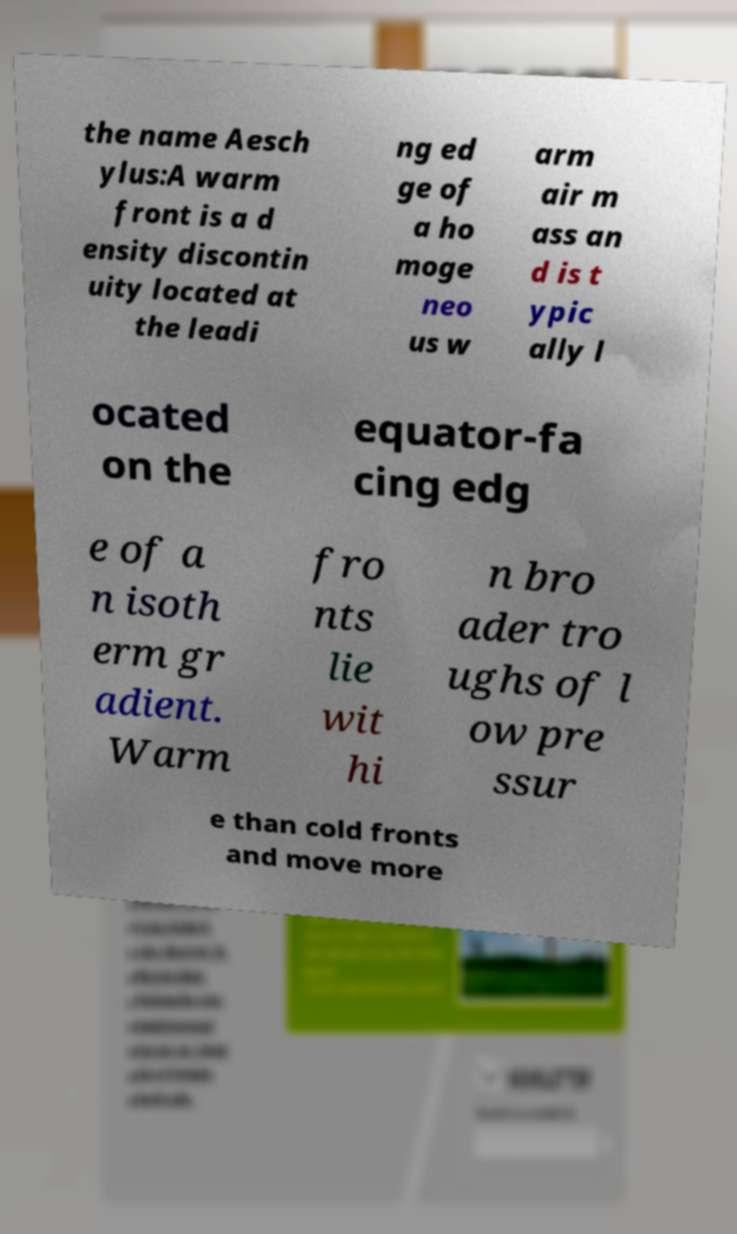Please identify and transcribe the text found in this image. the name Aesch ylus:A warm front is a d ensity discontin uity located at the leadi ng ed ge of a ho moge neo us w arm air m ass an d is t ypic ally l ocated on the equator-fa cing edg e of a n isoth erm gr adient. Warm fro nts lie wit hi n bro ader tro ughs of l ow pre ssur e than cold fronts and move more 